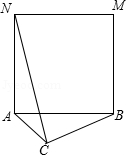As shown in the figure, it is known that in triangle ABC, AC = 2.0, BC = 4.0, and AB is the side shape to make a square ABMN. If the degree of angle ACB changes and connects to CN, the maximum value of CN is? In tackling this intriguing geometry puzzle, we visualize the scenario where triangle ACB pivots around point A. Our goal - to deduce the longest possible length of line CN. Insightfully, we observe that ABMN forms a perfect square, mandating that AB equals AN and that angle BAN is a precise 90 degrees. This realization is instrumental. Upon rotating triangle ACB a quarter turn counterclockwise considering A as our pivot, the image of point C, which we'll label C', alights upon the line segment CN perfectly, when C' and N coincide for the maximal length. Triangle ACC' reveals itself to be an isosceles right triangle, yielding CC' as 2√2, the product of AC and the square root of two. A law of triangles whispers that the sum of NC' and CC' can only ever be greater than the original CN unless C rests on the segment itself. Thus, when C' amalgamates with N, CN achieves its zenith, measuring at an impressive 4+2√2. It is in full accordance with mathematical law that we declare answer C the victor of our geometric quest. 